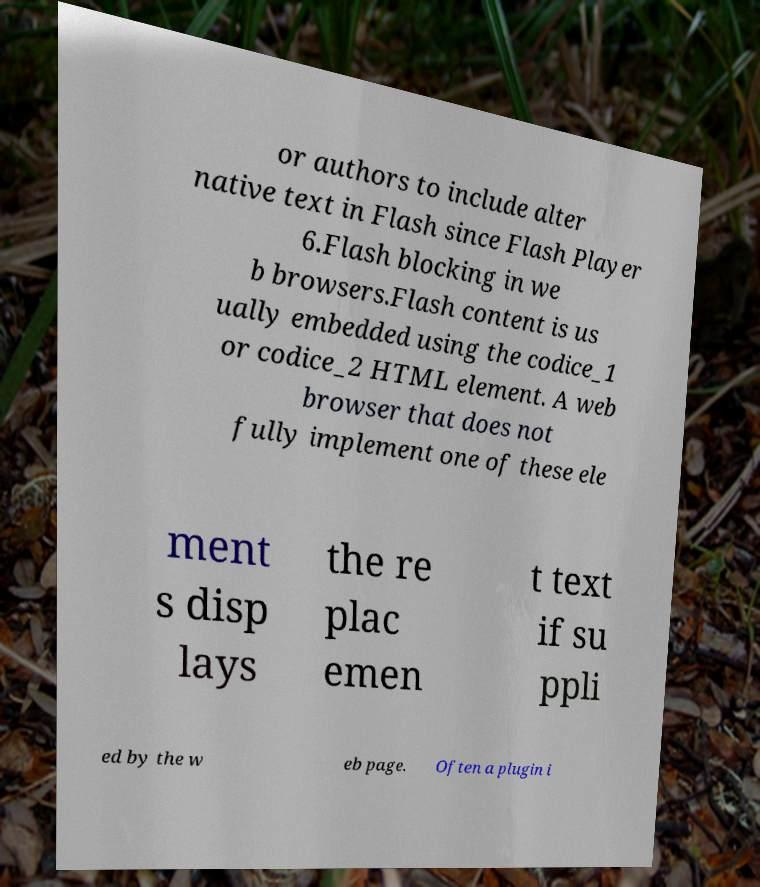For documentation purposes, I need the text within this image transcribed. Could you provide that? or authors to include alter native text in Flash since Flash Player 6.Flash blocking in we b browsers.Flash content is us ually embedded using the codice_1 or codice_2 HTML element. A web browser that does not fully implement one of these ele ment s disp lays the re plac emen t text if su ppli ed by the w eb page. Often a plugin i 